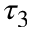<formula> <loc_0><loc_0><loc_500><loc_500>\tau _ { 3 }</formula> 